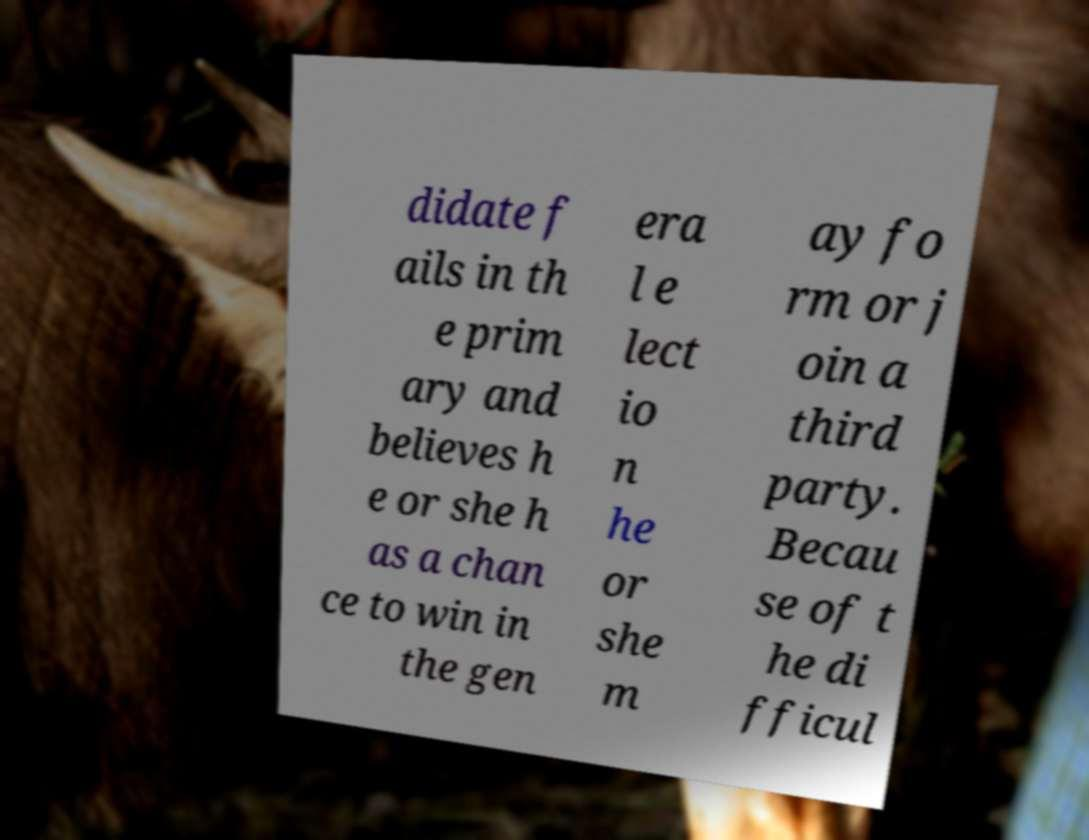Could you assist in decoding the text presented in this image and type it out clearly? didate f ails in th e prim ary and believes h e or she h as a chan ce to win in the gen era l e lect io n he or she m ay fo rm or j oin a third party. Becau se of t he di fficul 